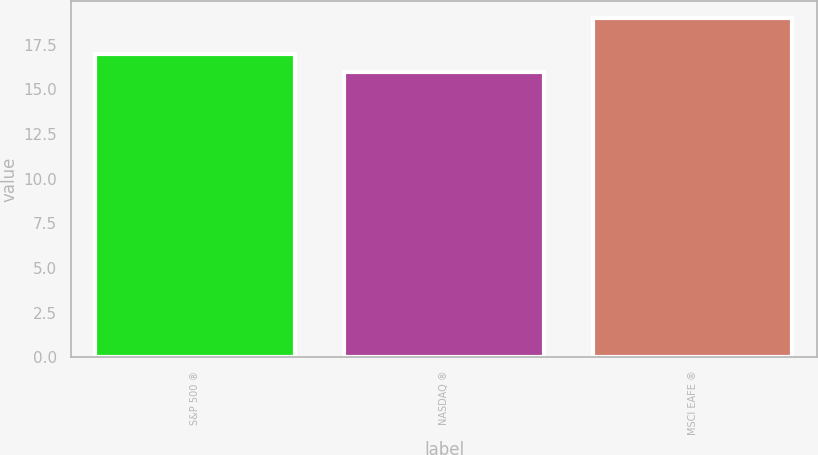<chart> <loc_0><loc_0><loc_500><loc_500><bar_chart><fcel>S&P 500 ®<fcel>NASDAQ ®<fcel>MSCI EAFE ®<nl><fcel>17<fcel>16<fcel>19<nl></chart> 